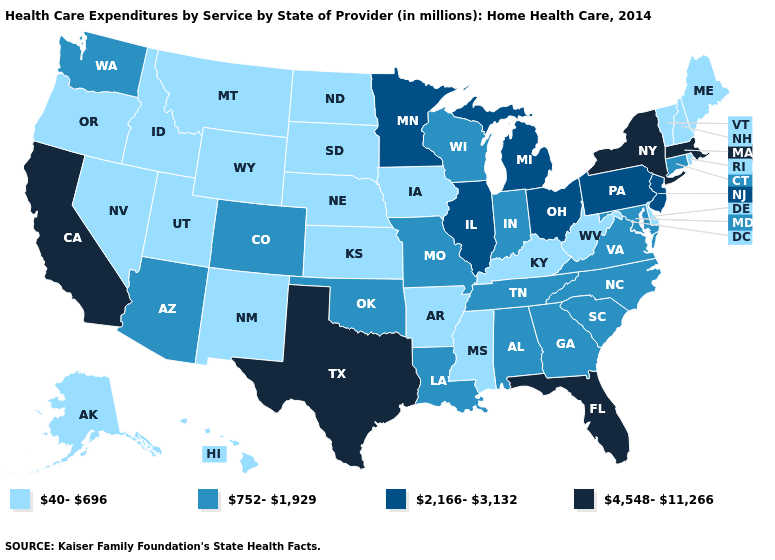What is the value of Mississippi?
Quick response, please. 40-696. What is the value of Utah?
Concise answer only. 40-696. What is the value of Massachusetts?
Short answer required. 4,548-11,266. Which states have the lowest value in the USA?
Answer briefly. Alaska, Arkansas, Delaware, Hawaii, Idaho, Iowa, Kansas, Kentucky, Maine, Mississippi, Montana, Nebraska, Nevada, New Hampshire, New Mexico, North Dakota, Oregon, Rhode Island, South Dakota, Utah, Vermont, West Virginia, Wyoming. Name the states that have a value in the range 2,166-3,132?
Answer briefly. Illinois, Michigan, Minnesota, New Jersey, Ohio, Pennsylvania. What is the value of West Virginia?
Keep it brief. 40-696. What is the value of Massachusetts?
Write a very short answer. 4,548-11,266. Name the states that have a value in the range 40-696?
Answer briefly. Alaska, Arkansas, Delaware, Hawaii, Idaho, Iowa, Kansas, Kentucky, Maine, Mississippi, Montana, Nebraska, Nevada, New Hampshire, New Mexico, North Dakota, Oregon, Rhode Island, South Dakota, Utah, Vermont, West Virginia, Wyoming. What is the highest value in the USA?
Short answer required. 4,548-11,266. Name the states that have a value in the range 752-1,929?
Short answer required. Alabama, Arizona, Colorado, Connecticut, Georgia, Indiana, Louisiana, Maryland, Missouri, North Carolina, Oklahoma, South Carolina, Tennessee, Virginia, Washington, Wisconsin. Is the legend a continuous bar?
Keep it brief. No. What is the value of Texas?
Answer briefly. 4,548-11,266. Name the states that have a value in the range 752-1,929?
Short answer required. Alabama, Arizona, Colorado, Connecticut, Georgia, Indiana, Louisiana, Maryland, Missouri, North Carolina, Oklahoma, South Carolina, Tennessee, Virginia, Washington, Wisconsin. 